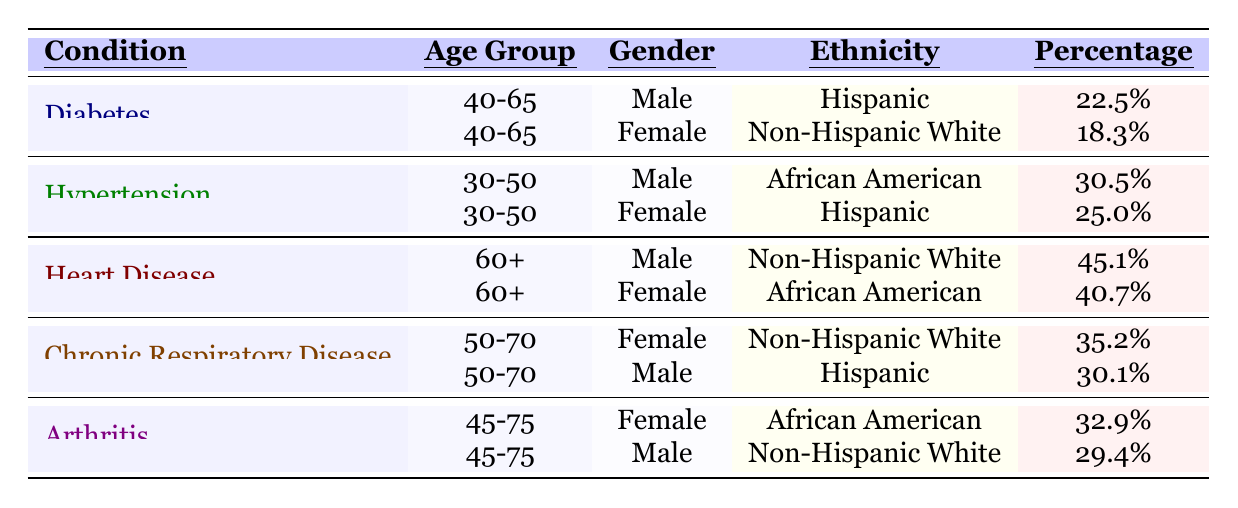What percentage of males aged 40-65 have Diabetes? According to the table, the percentage of males aged 40-65 with Diabetes is listed as 22.5%.
Answer: 22.5% What is the ethnicity of females with Hypertension in the age group 30-50? The table indicates that females aged 30-50 with Hypertension are of Hispanic ethnicity.
Answer: Hispanic Which chronic condition has the highest prevalence among patients aged 60 or older? The table shows that Heart Disease has the highest prevalence at 45.1% for males aged 60+ and 40.7% for females aged 60+.
Answer: Heart Disease Is the percentage of female Arthritis patients who are African American greater than that of male Diabetes patients who are Hispanic? By comparing the values, the percentage of female Arthritis patients who are African American is 32.9%, and the percentage of male Diabetes patients who are Hispanic is 22.5%. Since 32.9% is greater than 22.5%, the answer is yes.
Answer: Yes What is the overall percentage of males with Chronic Respiratory Disease? To find this, we look for males in the Chronic Respiratory Disease section: the percentage for males is 30.1%. There’s only one entry for males, so that's the overall percentage.
Answer: 30.1% What is the difference between the prevalence of Hypertension in African American males and Hispanic females? The prevalence of Hypertension in African American males is 30.5%, while in Hispanic females, it is 25.0%. The difference is 30.5% - 25.0% = 5.5%.
Answer: 5.5% How many patients aged 50-70 have Chronic Respiratory Disease across genders? From the table, there are two entries for those aged 50-70—one female at 35.2% and one male at 30.1%. Since the question refers to the totality, we need to consider both genders: thus, there are two patients represented in the table.
Answer: 2 What percentage of Diabetes patients are non-Hispanic White females? The table shows that 18.3% of Diabetes patients are non-Hispanic White females, as indicated in their specific entry.
Answer: 18.3% Which condition has a higher prevalence among females aged 60+ compared to males aged 40-65? Female prevalence for Heart Disease (40.7%) in the group aged 60+ is compared to male Diabetes prevalence (22.5%) for the group aged 40-65. Since 40.7% is greater than 22.5%, the answer is Heart Disease.
Answer: Heart Disease Are there more African American females with Heart Disease than Hispanic females with Diabetes? The table shows that the percentage of African American females with Heart Disease is 40.7%, while that of Hispanic females with Diabetes is 18.3%. Since 40.7% is greater than 18.3%, the answer is yes.
Answer: Yes 